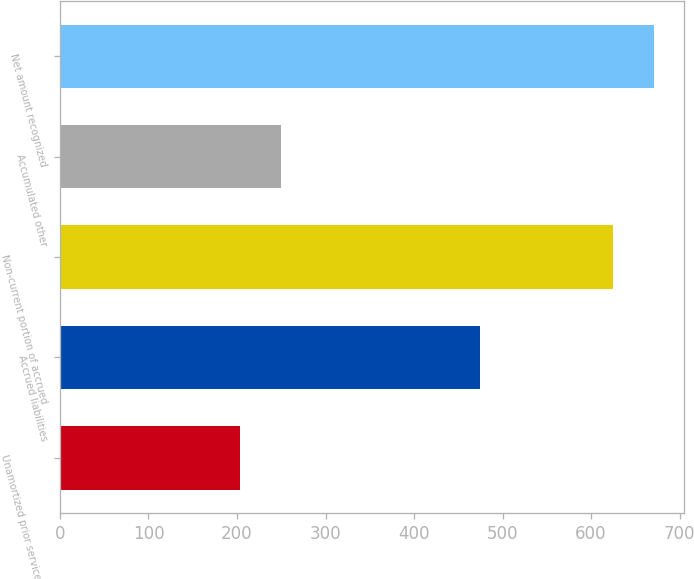<chart> <loc_0><loc_0><loc_500><loc_500><bar_chart><fcel>Unamortized prior service cost<fcel>Accrued liabilities<fcel>Non-current portion of accrued<fcel>Accumulated other<fcel>Net amount recognized<nl><fcel>203<fcel>475<fcel>625<fcel>249.5<fcel>671.5<nl></chart> 